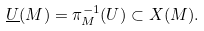<formula> <loc_0><loc_0><loc_500><loc_500>\underline { U } ( M ) = \pi _ { M } ^ { - 1 } ( U ) \subset X ( M ) .</formula> 